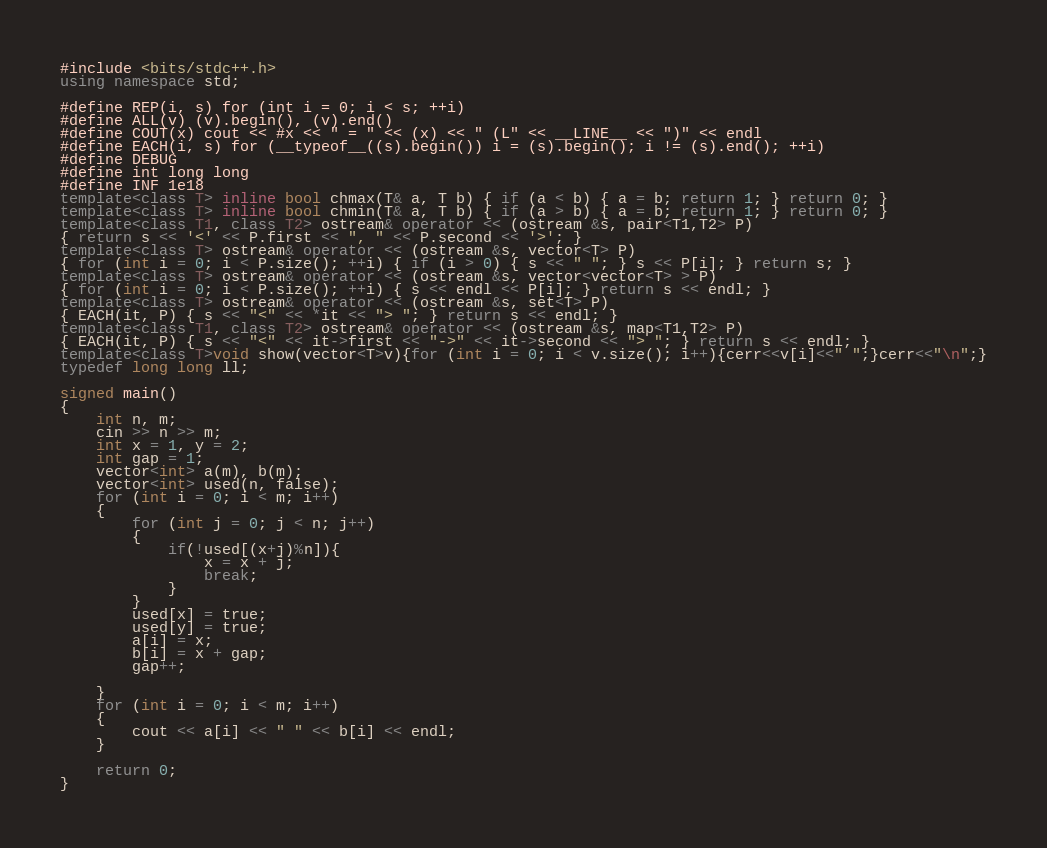<code> <loc_0><loc_0><loc_500><loc_500><_C++_>#include <bits/stdc++.h>
using namespace std;
 
#define REP(i, s) for (int i = 0; i < s; ++i)
#define ALL(v) (v).begin(), (v).end()
#define COUT(x) cout << #x << " = " << (x) << " (L" << __LINE__ << ")" << endl
#define EACH(i, s) for (__typeof__((s).begin()) i = (s).begin(); i != (s).end(); ++i)
#define DEBUG
#define int long long
#define INF 1e18
template<class T> inline bool chmax(T& a, T b) { if (a < b) { a = b; return 1; } return 0; }
template<class T> inline bool chmin(T& a, T b) { if (a > b) { a = b; return 1; } return 0; }
template<class T1, class T2> ostream& operator << (ostream &s, pair<T1,T2> P)
{ return s << '<' << P.first << ", " << P.second << '>'; }
template<class T> ostream& operator << (ostream &s, vector<T> P)
{ for (int i = 0; i < P.size(); ++i) { if (i > 0) { s << " "; } s << P[i]; } return s; }
template<class T> ostream& operator << (ostream &s, vector<vector<T> > P)
{ for (int i = 0; i < P.size(); ++i) { s << endl << P[i]; } return s << endl; }
template<class T> ostream& operator << (ostream &s, set<T> P)
{ EACH(it, P) { s << "<" << *it << "> "; } return s << endl; }
template<class T1, class T2> ostream& operator << (ostream &s, map<T1,T2> P)
{ EACH(it, P) { s << "<" << it->first << "->" << it->second << "> "; } return s << endl; }
template<class T>void show(vector<T>v){for (int i = 0; i < v.size(); i++){cerr<<v[i]<<" ";}cerr<<"\n";}
typedef long long ll;

signed main()
{
    int n, m;
    cin >> n >> m;
    int x = 1, y = 2;
    int gap = 1;
    vector<int> a(m), b(m);
    vector<int> used(n, false);
    for (int i = 0; i < m; i++)
    {
        for (int j = 0; j < n; j++)
        {
            if(!used[(x+j)%n]){
                x = x + j;
                break;
            }
        }
        used[x] = true;
        used[y] = true;
        a[i] = x;
        b[i] = x + gap;
        gap++;
    
    }
    for (int i = 0; i < m; i++)
    {
        cout << a[i] << " " << b[i] << endl;
    }

    return 0;
}</code> 